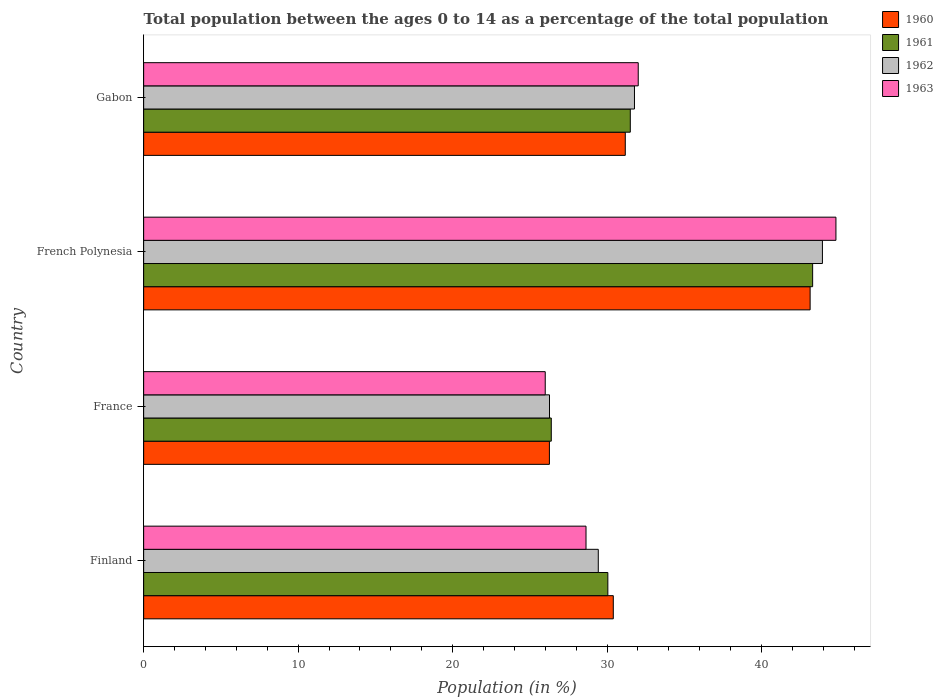How many different coloured bars are there?
Give a very brief answer. 4. How many groups of bars are there?
Keep it short and to the point. 4. How many bars are there on the 4th tick from the top?
Provide a short and direct response. 4. How many bars are there on the 1st tick from the bottom?
Ensure brevity in your answer.  4. What is the label of the 3rd group of bars from the top?
Your response must be concise. France. What is the percentage of the population ages 0 to 14 in 1962 in French Polynesia?
Make the answer very short. 43.94. Across all countries, what is the maximum percentage of the population ages 0 to 14 in 1961?
Give a very brief answer. 43.31. Across all countries, what is the minimum percentage of the population ages 0 to 14 in 1961?
Offer a very short reply. 26.39. In which country was the percentage of the population ages 0 to 14 in 1963 maximum?
Ensure brevity in your answer.  French Polynesia. What is the total percentage of the population ages 0 to 14 in 1963 in the graph?
Your response must be concise. 131.46. What is the difference between the percentage of the population ages 0 to 14 in 1962 in France and that in French Polynesia?
Provide a short and direct response. -17.67. What is the difference between the percentage of the population ages 0 to 14 in 1962 in Gabon and the percentage of the population ages 0 to 14 in 1961 in Finland?
Your answer should be compact. 1.72. What is the average percentage of the population ages 0 to 14 in 1960 per country?
Give a very brief answer. 32.75. What is the difference between the percentage of the population ages 0 to 14 in 1962 and percentage of the population ages 0 to 14 in 1963 in Finland?
Your answer should be compact. 0.79. What is the ratio of the percentage of the population ages 0 to 14 in 1963 in Finland to that in France?
Provide a short and direct response. 1.1. Is the percentage of the population ages 0 to 14 in 1962 in Finland less than that in French Polynesia?
Your response must be concise. Yes. Is the difference between the percentage of the population ages 0 to 14 in 1962 in French Polynesia and Gabon greater than the difference between the percentage of the population ages 0 to 14 in 1963 in French Polynesia and Gabon?
Ensure brevity in your answer.  No. What is the difference between the highest and the second highest percentage of the population ages 0 to 14 in 1961?
Offer a very short reply. 11.8. What is the difference between the highest and the lowest percentage of the population ages 0 to 14 in 1961?
Your answer should be compact. 16.92. What does the 2nd bar from the top in France represents?
Keep it short and to the point. 1962. Is it the case that in every country, the sum of the percentage of the population ages 0 to 14 in 1963 and percentage of the population ages 0 to 14 in 1960 is greater than the percentage of the population ages 0 to 14 in 1962?
Give a very brief answer. Yes. How many bars are there?
Keep it short and to the point. 16. Are all the bars in the graph horizontal?
Offer a very short reply. Yes. How many countries are there in the graph?
Make the answer very short. 4. What is the difference between two consecutive major ticks on the X-axis?
Your answer should be compact. 10. Are the values on the major ticks of X-axis written in scientific E-notation?
Keep it short and to the point. No. Does the graph contain grids?
Provide a succinct answer. No. How are the legend labels stacked?
Your answer should be compact. Vertical. What is the title of the graph?
Give a very brief answer. Total population between the ages 0 to 14 as a percentage of the total population. Does "1960" appear as one of the legend labels in the graph?
Ensure brevity in your answer.  Yes. What is the label or title of the X-axis?
Ensure brevity in your answer.  Population (in %). What is the label or title of the Y-axis?
Your answer should be compact. Country. What is the Population (in %) of 1960 in Finland?
Make the answer very short. 30.4. What is the Population (in %) in 1961 in Finland?
Make the answer very short. 30.05. What is the Population (in %) in 1962 in Finland?
Your answer should be very brief. 29.43. What is the Population (in %) of 1963 in Finland?
Keep it short and to the point. 28.64. What is the Population (in %) of 1960 in France?
Your answer should be very brief. 26.27. What is the Population (in %) of 1961 in France?
Provide a short and direct response. 26.39. What is the Population (in %) of 1962 in France?
Offer a very short reply. 26.27. What is the Population (in %) in 1963 in France?
Give a very brief answer. 26. What is the Population (in %) of 1960 in French Polynesia?
Keep it short and to the point. 43.14. What is the Population (in %) of 1961 in French Polynesia?
Your answer should be very brief. 43.31. What is the Population (in %) in 1962 in French Polynesia?
Your answer should be very brief. 43.94. What is the Population (in %) in 1963 in French Polynesia?
Ensure brevity in your answer.  44.81. What is the Population (in %) of 1960 in Gabon?
Your answer should be very brief. 31.18. What is the Population (in %) in 1961 in Gabon?
Offer a terse response. 31.5. What is the Population (in %) of 1962 in Gabon?
Your answer should be very brief. 31.77. What is the Population (in %) in 1963 in Gabon?
Make the answer very short. 32.02. Across all countries, what is the maximum Population (in %) of 1960?
Offer a very short reply. 43.14. Across all countries, what is the maximum Population (in %) of 1961?
Keep it short and to the point. 43.31. Across all countries, what is the maximum Population (in %) of 1962?
Your response must be concise. 43.94. Across all countries, what is the maximum Population (in %) in 1963?
Your answer should be compact. 44.81. Across all countries, what is the minimum Population (in %) in 1960?
Your answer should be compact. 26.27. Across all countries, what is the minimum Population (in %) in 1961?
Offer a very short reply. 26.39. Across all countries, what is the minimum Population (in %) of 1962?
Your response must be concise. 26.27. Across all countries, what is the minimum Population (in %) of 1963?
Keep it short and to the point. 26. What is the total Population (in %) in 1960 in the graph?
Your response must be concise. 130.99. What is the total Population (in %) in 1961 in the graph?
Your answer should be very brief. 131.24. What is the total Population (in %) of 1962 in the graph?
Keep it short and to the point. 131.41. What is the total Population (in %) in 1963 in the graph?
Provide a short and direct response. 131.46. What is the difference between the Population (in %) in 1960 in Finland and that in France?
Make the answer very short. 4.14. What is the difference between the Population (in %) in 1961 in Finland and that in France?
Provide a short and direct response. 3.66. What is the difference between the Population (in %) of 1962 in Finland and that in France?
Keep it short and to the point. 3.16. What is the difference between the Population (in %) in 1963 in Finland and that in France?
Give a very brief answer. 2.64. What is the difference between the Population (in %) in 1960 in Finland and that in French Polynesia?
Offer a terse response. -12.74. What is the difference between the Population (in %) in 1961 in Finland and that in French Polynesia?
Your answer should be very brief. -13.26. What is the difference between the Population (in %) in 1962 in Finland and that in French Polynesia?
Keep it short and to the point. -14.51. What is the difference between the Population (in %) in 1963 in Finland and that in French Polynesia?
Provide a succinct answer. -16.18. What is the difference between the Population (in %) in 1960 in Finland and that in Gabon?
Provide a short and direct response. -0.78. What is the difference between the Population (in %) in 1961 in Finland and that in Gabon?
Keep it short and to the point. -1.45. What is the difference between the Population (in %) in 1962 in Finland and that in Gabon?
Your response must be concise. -2.34. What is the difference between the Population (in %) of 1963 in Finland and that in Gabon?
Make the answer very short. -3.38. What is the difference between the Population (in %) in 1960 in France and that in French Polynesia?
Your response must be concise. -16.88. What is the difference between the Population (in %) of 1961 in France and that in French Polynesia?
Provide a succinct answer. -16.92. What is the difference between the Population (in %) in 1962 in France and that in French Polynesia?
Provide a short and direct response. -17.67. What is the difference between the Population (in %) of 1963 in France and that in French Polynesia?
Offer a terse response. -18.82. What is the difference between the Population (in %) in 1960 in France and that in Gabon?
Your answer should be compact. -4.91. What is the difference between the Population (in %) of 1961 in France and that in Gabon?
Your response must be concise. -5.11. What is the difference between the Population (in %) in 1962 in France and that in Gabon?
Make the answer very short. -5.5. What is the difference between the Population (in %) of 1963 in France and that in Gabon?
Provide a succinct answer. -6.02. What is the difference between the Population (in %) of 1960 in French Polynesia and that in Gabon?
Provide a succinct answer. 11.96. What is the difference between the Population (in %) in 1961 in French Polynesia and that in Gabon?
Provide a short and direct response. 11.8. What is the difference between the Population (in %) of 1962 in French Polynesia and that in Gabon?
Give a very brief answer. 12.17. What is the difference between the Population (in %) of 1963 in French Polynesia and that in Gabon?
Your answer should be very brief. 12.8. What is the difference between the Population (in %) in 1960 in Finland and the Population (in %) in 1961 in France?
Your answer should be compact. 4.01. What is the difference between the Population (in %) in 1960 in Finland and the Population (in %) in 1962 in France?
Offer a very short reply. 4.13. What is the difference between the Population (in %) in 1960 in Finland and the Population (in %) in 1963 in France?
Provide a short and direct response. 4.41. What is the difference between the Population (in %) in 1961 in Finland and the Population (in %) in 1962 in France?
Your answer should be very brief. 3.78. What is the difference between the Population (in %) of 1961 in Finland and the Population (in %) of 1963 in France?
Keep it short and to the point. 4.05. What is the difference between the Population (in %) of 1962 in Finland and the Population (in %) of 1963 in France?
Your answer should be very brief. 3.43. What is the difference between the Population (in %) in 1960 in Finland and the Population (in %) in 1961 in French Polynesia?
Provide a succinct answer. -12.9. What is the difference between the Population (in %) in 1960 in Finland and the Population (in %) in 1962 in French Polynesia?
Your response must be concise. -13.54. What is the difference between the Population (in %) in 1960 in Finland and the Population (in %) in 1963 in French Polynesia?
Provide a succinct answer. -14.41. What is the difference between the Population (in %) of 1961 in Finland and the Population (in %) of 1962 in French Polynesia?
Provide a succinct answer. -13.89. What is the difference between the Population (in %) in 1961 in Finland and the Population (in %) in 1963 in French Polynesia?
Provide a succinct answer. -14.77. What is the difference between the Population (in %) of 1962 in Finland and the Population (in %) of 1963 in French Polynesia?
Your response must be concise. -15.38. What is the difference between the Population (in %) in 1960 in Finland and the Population (in %) in 1961 in Gabon?
Offer a terse response. -1.1. What is the difference between the Population (in %) of 1960 in Finland and the Population (in %) of 1962 in Gabon?
Make the answer very short. -1.37. What is the difference between the Population (in %) in 1960 in Finland and the Population (in %) in 1963 in Gabon?
Give a very brief answer. -1.61. What is the difference between the Population (in %) of 1961 in Finland and the Population (in %) of 1962 in Gabon?
Keep it short and to the point. -1.72. What is the difference between the Population (in %) of 1961 in Finland and the Population (in %) of 1963 in Gabon?
Provide a succinct answer. -1.97. What is the difference between the Population (in %) of 1962 in Finland and the Population (in %) of 1963 in Gabon?
Give a very brief answer. -2.59. What is the difference between the Population (in %) in 1960 in France and the Population (in %) in 1961 in French Polynesia?
Your response must be concise. -17.04. What is the difference between the Population (in %) in 1960 in France and the Population (in %) in 1962 in French Polynesia?
Offer a very short reply. -17.67. What is the difference between the Population (in %) of 1960 in France and the Population (in %) of 1963 in French Polynesia?
Provide a short and direct response. -18.55. What is the difference between the Population (in %) in 1961 in France and the Population (in %) in 1962 in French Polynesia?
Your response must be concise. -17.55. What is the difference between the Population (in %) of 1961 in France and the Population (in %) of 1963 in French Polynesia?
Keep it short and to the point. -18.43. What is the difference between the Population (in %) in 1962 in France and the Population (in %) in 1963 in French Polynesia?
Ensure brevity in your answer.  -18.54. What is the difference between the Population (in %) of 1960 in France and the Population (in %) of 1961 in Gabon?
Ensure brevity in your answer.  -5.24. What is the difference between the Population (in %) in 1960 in France and the Population (in %) in 1962 in Gabon?
Make the answer very short. -5.51. What is the difference between the Population (in %) of 1960 in France and the Population (in %) of 1963 in Gabon?
Offer a very short reply. -5.75. What is the difference between the Population (in %) of 1961 in France and the Population (in %) of 1962 in Gabon?
Keep it short and to the point. -5.39. What is the difference between the Population (in %) of 1961 in France and the Population (in %) of 1963 in Gabon?
Your response must be concise. -5.63. What is the difference between the Population (in %) in 1962 in France and the Population (in %) in 1963 in Gabon?
Your answer should be very brief. -5.74. What is the difference between the Population (in %) in 1960 in French Polynesia and the Population (in %) in 1961 in Gabon?
Provide a succinct answer. 11.64. What is the difference between the Population (in %) of 1960 in French Polynesia and the Population (in %) of 1962 in Gabon?
Make the answer very short. 11.37. What is the difference between the Population (in %) in 1960 in French Polynesia and the Population (in %) in 1963 in Gabon?
Your answer should be compact. 11.13. What is the difference between the Population (in %) in 1961 in French Polynesia and the Population (in %) in 1962 in Gabon?
Provide a short and direct response. 11.53. What is the difference between the Population (in %) of 1961 in French Polynesia and the Population (in %) of 1963 in Gabon?
Provide a short and direct response. 11.29. What is the difference between the Population (in %) in 1962 in French Polynesia and the Population (in %) in 1963 in Gabon?
Offer a very short reply. 11.92. What is the average Population (in %) of 1960 per country?
Ensure brevity in your answer.  32.75. What is the average Population (in %) in 1961 per country?
Your answer should be very brief. 32.81. What is the average Population (in %) in 1962 per country?
Ensure brevity in your answer.  32.85. What is the average Population (in %) of 1963 per country?
Your response must be concise. 32.87. What is the difference between the Population (in %) of 1960 and Population (in %) of 1961 in Finland?
Keep it short and to the point. 0.35. What is the difference between the Population (in %) in 1960 and Population (in %) in 1962 in Finland?
Offer a very short reply. 0.97. What is the difference between the Population (in %) in 1960 and Population (in %) in 1963 in Finland?
Make the answer very short. 1.77. What is the difference between the Population (in %) of 1961 and Population (in %) of 1962 in Finland?
Give a very brief answer. 0.62. What is the difference between the Population (in %) of 1961 and Population (in %) of 1963 in Finland?
Offer a very short reply. 1.41. What is the difference between the Population (in %) in 1962 and Population (in %) in 1963 in Finland?
Provide a short and direct response. 0.79. What is the difference between the Population (in %) of 1960 and Population (in %) of 1961 in France?
Provide a succinct answer. -0.12. What is the difference between the Population (in %) of 1960 and Population (in %) of 1962 in France?
Offer a terse response. -0.01. What is the difference between the Population (in %) of 1960 and Population (in %) of 1963 in France?
Provide a succinct answer. 0.27. What is the difference between the Population (in %) of 1961 and Population (in %) of 1962 in France?
Offer a terse response. 0.12. What is the difference between the Population (in %) in 1961 and Population (in %) in 1963 in France?
Offer a terse response. 0.39. What is the difference between the Population (in %) in 1962 and Population (in %) in 1963 in France?
Provide a succinct answer. 0.28. What is the difference between the Population (in %) in 1960 and Population (in %) in 1961 in French Polynesia?
Provide a short and direct response. -0.16. What is the difference between the Population (in %) in 1960 and Population (in %) in 1962 in French Polynesia?
Provide a short and direct response. -0.8. What is the difference between the Population (in %) of 1960 and Population (in %) of 1963 in French Polynesia?
Your answer should be very brief. -1.67. What is the difference between the Population (in %) of 1961 and Population (in %) of 1962 in French Polynesia?
Make the answer very short. -0.63. What is the difference between the Population (in %) of 1961 and Population (in %) of 1963 in French Polynesia?
Give a very brief answer. -1.51. What is the difference between the Population (in %) in 1962 and Population (in %) in 1963 in French Polynesia?
Offer a terse response. -0.87. What is the difference between the Population (in %) in 1960 and Population (in %) in 1961 in Gabon?
Keep it short and to the point. -0.32. What is the difference between the Population (in %) in 1960 and Population (in %) in 1962 in Gabon?
Your answer should be very brief. -0.59. What is the difference between the Population (in %) in 1960 and Population (in %) in 1963 in Gabon?
Give a very brief answer. -0.84. What is the difference between the Population (in %) of 1961 and Population (in %) of 1962 in Gabon?
Ensure brevity in your answer.  -0.27. What is the difference between the Population (in %) of 1961 and Population (in %) of 1963 in Gabon?
Provide a succinct answer. -0.51. What is the difference between the Population (in %) of 1962 and Population (in %) of 1963 in Gabon?
Provide a short and direct response. -0.24. What is the ratio of the Population (in %) in 1960 in Finland to that in France?
Provide a succinct answer. 1.16. What is the ratio of the Population (in %) in 1961 in Finland to that in France?
Make the answer very short. 1.14. What is the ratio of the Population (in %) in 1962 in Finland to that in France?
Keep it short and to the point. 1.12. What is the ratio of the Population (in %) in 1963 in Finland to that in France?
Make the answer very short. 1.1. What is the ratio of the Population (in %) in 1960 in Finland to that in French Polynesia?
Make the answer very short. 0.7. What is the ratio of the Population (in %) in 1961 in Finland to that in French Polynesia?
Ensure brevity in your answer.  0.69. What is the ratio of the Population (in %) of 1962 in Finland to that in French Polynesia?
Keep it short and to the point. 0.67. What is the ratio of the Population (in %) in 1963 in Finland to that in French Polynesia?
Offer a very short reply. 0.64. What is the ratio of the Population (in %) in 1960 in Finland to that in Gabon?
Offer a terse response. 0.98. What is the ratio of the Population (in %) of 1961 in Finland to that in Gabon?
Offer a very short reply. 0.95. What is the ratio of the Population (in %) in 1962 in Finland to that in Gabon?
Give a very brief answer. 0.93. What is the ratio of the Population (in %) in 1963 in Finland to that in Gabon?
Give a very brief answer. 0.89. What is the ratio of the Population (in %) in 1960 in France to that in French Polynesia?
Provide a succinct answer. 0.61. What is the ratio of the Population (in %) in 1961 in France to that in French Polynesia?
Give a very brief answer. 0.61. What is the ratio of the Population (in %) in 1962 in France to that in French Polynesia?
Provide a succinct answer. 0.6. What is the ratio of the Population (in %) in 1963 in France to that in French Polynesia?
Provide a succinct answer. 0.58. What is the ratio of the Population (in %) in 1960 in France to that in Gabon?
Make the answer very short. 0.84. What is the ratio of the Population (in %) in 1961 in France to that in Gabon?
Give a very brief answer. 0.84. What is the ratio of the Population (in %) in 1962 in France to that in Gabon?
Make the answer very short. 0.83. What is the ratio of the Population (in %) in 1963 in France to that in Gabon?
Your answer should be compact. 0.81. What is the ratio of the Population (in %) in 1960 in French Polynesia to that in Gabon?
Give a very brief answer. 1.38. What is the ratio of the Population (in %) in 1961 in French Polynesia to that in Gabon?
Ensure brevity in your answer.  1.37. What is the ratio of the Population (in %) of 1962 in French Polynesia to that in Gabon?
Offer a very short reply. 1.38. What is the ratio of the Population (in %) of 1963 in French Polynesia to that in Gabon?
Your response must be concise. 1.4. What is the difference between the highest and the second highest Population (in %) of 1960?
Keep it short and to the point. 11.96. What is the difference between the highest and the second highest Population (in %) of 1961?
Ensure brevity in your answer.  11.8. What is the difference between the highest and the second highest Population (in %) in 1962?
Your response must be concise. 12.17. What is the difference between the highest and the second highest Population (in %) in 1963?
Make the answer very short. 12.8. What is the difference between the highest and the lowest Population (in %) of 1960?
Your response must be concise. 16.88. What is the difference between the highest and the lowest Population (in %) of 1961?
Make the answer very short. 16.92. What is the difference between the highest and the lowest Population (in %) of 1962?
Give a very brief answer. 17.67. What is the difference between the highest and the lowest Population (in %) in 1963?
Make the answer very short. 18.82. 